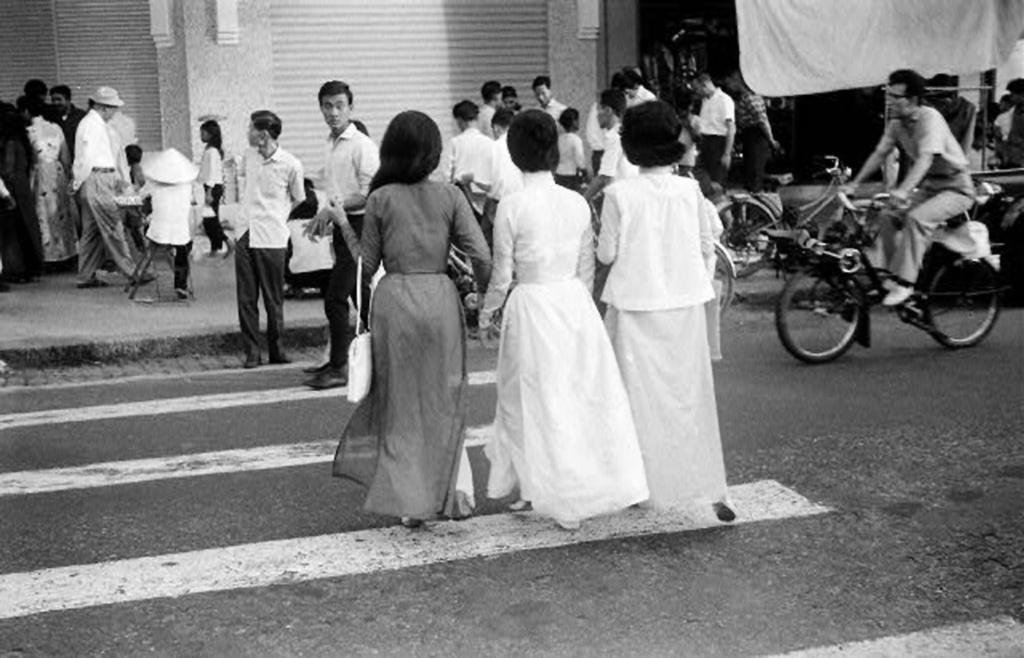Can you describe this image briefly? In this image, there is a road, there is zebra crossing on the road, there are some people crossing the road, at the right side there is a man riding a bicycle, at the background there are some people walking on the path. 